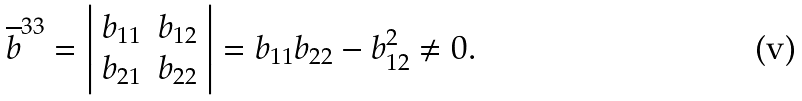<formula> <loc_0><loc_0><loc_500><loc_500>\overline { b } ^ { 3 3 } = \left | \begin{array} { c c } b _ { 1 1 } & b _ { 1 2 } \\ b _ { 2 1 } & b _ { 2 2 } \end{array} \right | = b _ { 1 1 } b _ { 2 2 } - b _ { 1 2 } ^ { 2 } \neq 0 .</formula> 